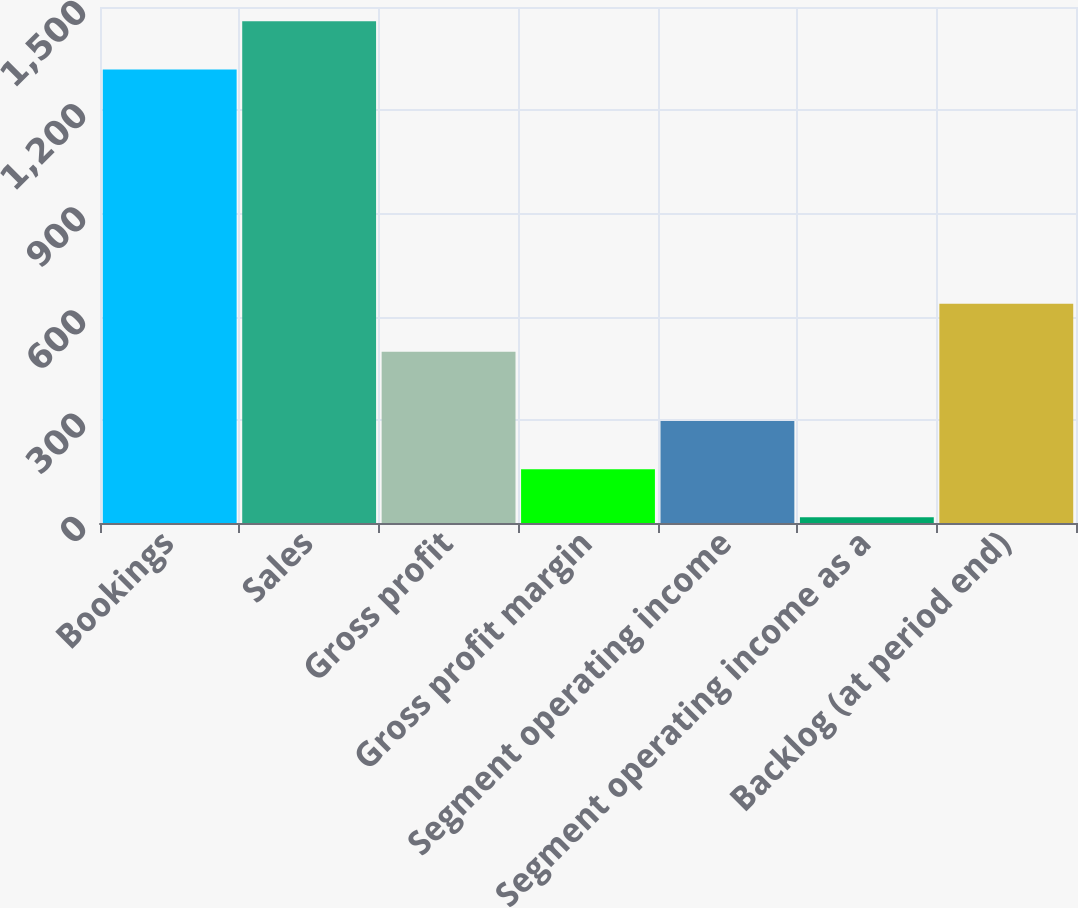<chart> <loc_0><loc_0><loc_500><loc_500><bar_chart><fcel>Bookings<fcel>Sales<fcel>Gross profit<fcel>Gross profit margin<fcel>Segment operating income<fcel>Segment operating income as a<fcel>Backlog (at period end)<nl><fcel>1318.5<fcel>1458.39<fcel>497.5<fcel>156.49<fcel>296.38<fcel>16.6<fcel>637.39<nl></chart> 